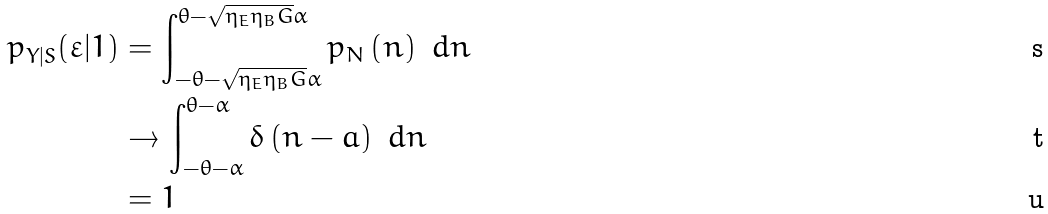Convert formula to latex. <formula><loc_0><loc_0><loc_500><loc_500>p _ { Y | S } ( \varepsilon | 1 ) & = \int _ { - \theta - \sqrt { \eta _ { E } \eta _ { B } G } \alpha } ^ { \theta - \sqrt { \eta _ { E } \eta _ { B } G } \alpha } p _ { N } \left ( n \right ) \ d n \\ & \rightarrow \int _ { - \theta - \alpha } ^ { \theta - \alpha } \delta \left ( n - a \right ) \ d n \\ & = 1</formula> 